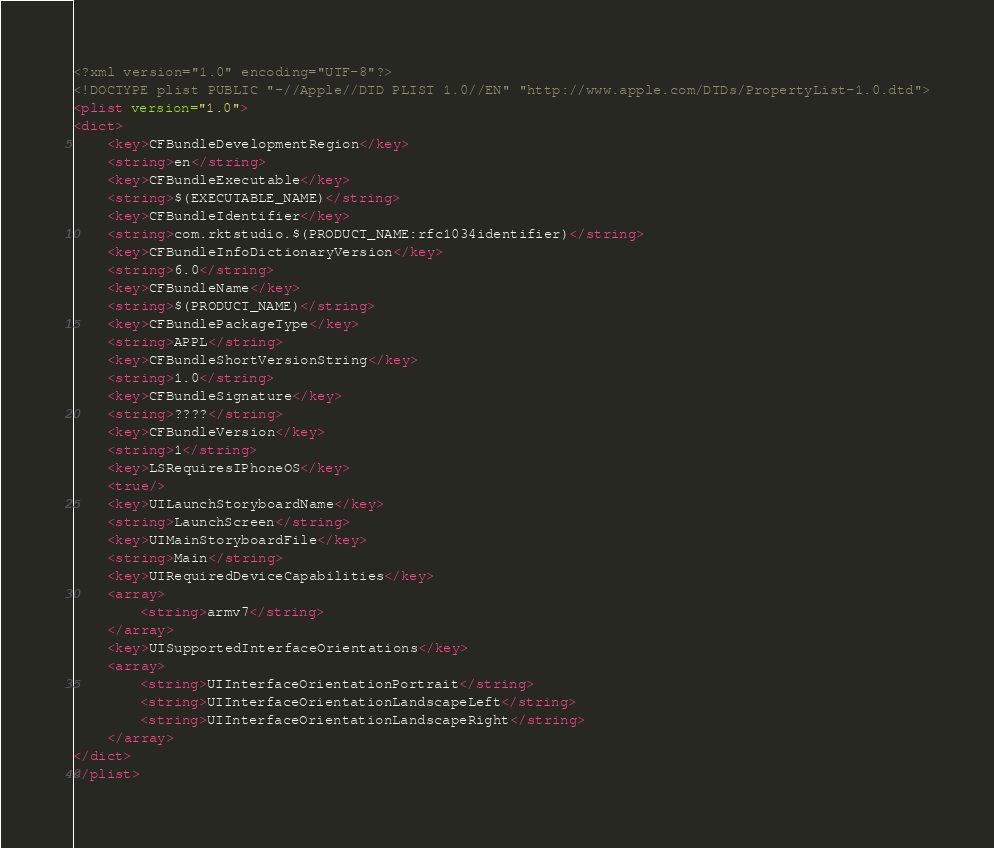<code> <loc_0><loc_0><loc_500><loc_500><_XML_><?xml version="1.0" encoding="UTF-8"?>
<!DOCTYPE plist PUBLIC "-//Apple//DTD PLIST 1.0//EN" "http://www.apple.com/DTDs/PropertyList-1.0.dtd">
<plist version="1.0">
<dict>
	<key>CFBundleDevelopmentRegion</key>
	<string>en</string>
	<key>CFBundleExecutable</key>
	<string>$(EXECUTABLE_NAME)</string>
	<key>CFBundleIdentifier</key>
	<string>com.rktstudio.$(PRODUCT_NAME:rfc1034identifier)</string>
	<key>CFBundleInfoDictionaryVersion</key>
	<string>6.0</string>
	<key>CFBundleName</key>
	<string>$(PRODUCT_NAME)</string>
	<key>CFBundlePackageType</key>
	<string>APPL</string>
	<key>CFBundleShortVersionString</key>
	<string>1.0</string>
	<key>CFBundleSignature</key>
	<string>????</string>
	<key>CFBundleVersion</key>
	<string>1</string>
	<key>LSRequiresIPhoneOS</key>
	<true/>
	<key>UILaunchStoryboardName</key>
	<string>LaunchScreen</string>
	<key>UIMainStoryboardFile</key>
	<string>Main</string>
	<key>UIRequiredDeviceCapabilities</key>
	<array>
		<string>armv7</string>
	</array>
	<key>UISupportedInterfaceOrientations</key>
	<array>
		<string>UIInterfaceOrientationPortrait</string>
		<string>UIInterfaceOrientationLandscapeLeft</string>
		<string>UIInterfaceOrientationLandscapeRight</string>
	</array>
</dict>
</plist>
</code> 